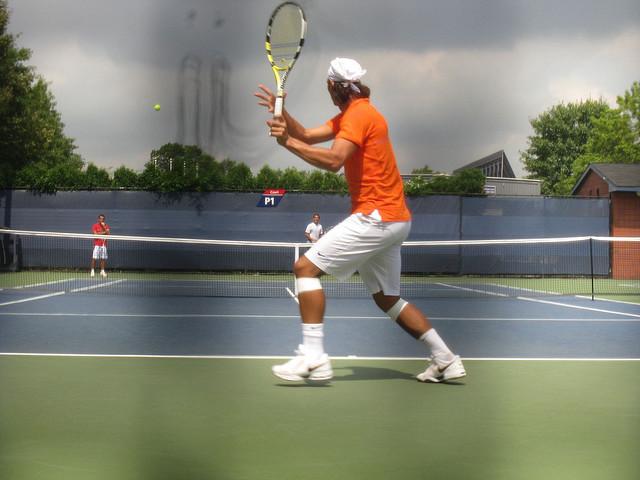Who is he playing against?
Write a very short answer. Opponent. Did the tennis player hit the ball to hard?
Quick response, please. Yes. How many knee braces is the closest player wearing?
Keep it brief. 2. 